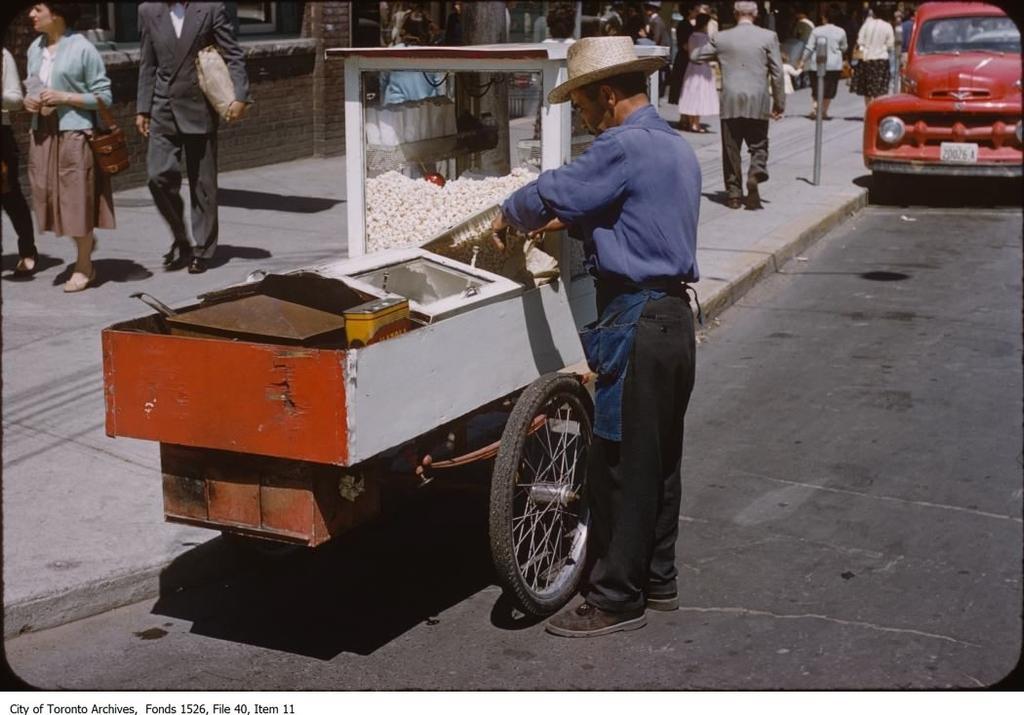Describe this image in one or two sentences. In the image we can see there are people standing on the footpath and there are vehicles parked on the road. There are popcorns in the box and behind there is a building. The building is made up of red bricks. 